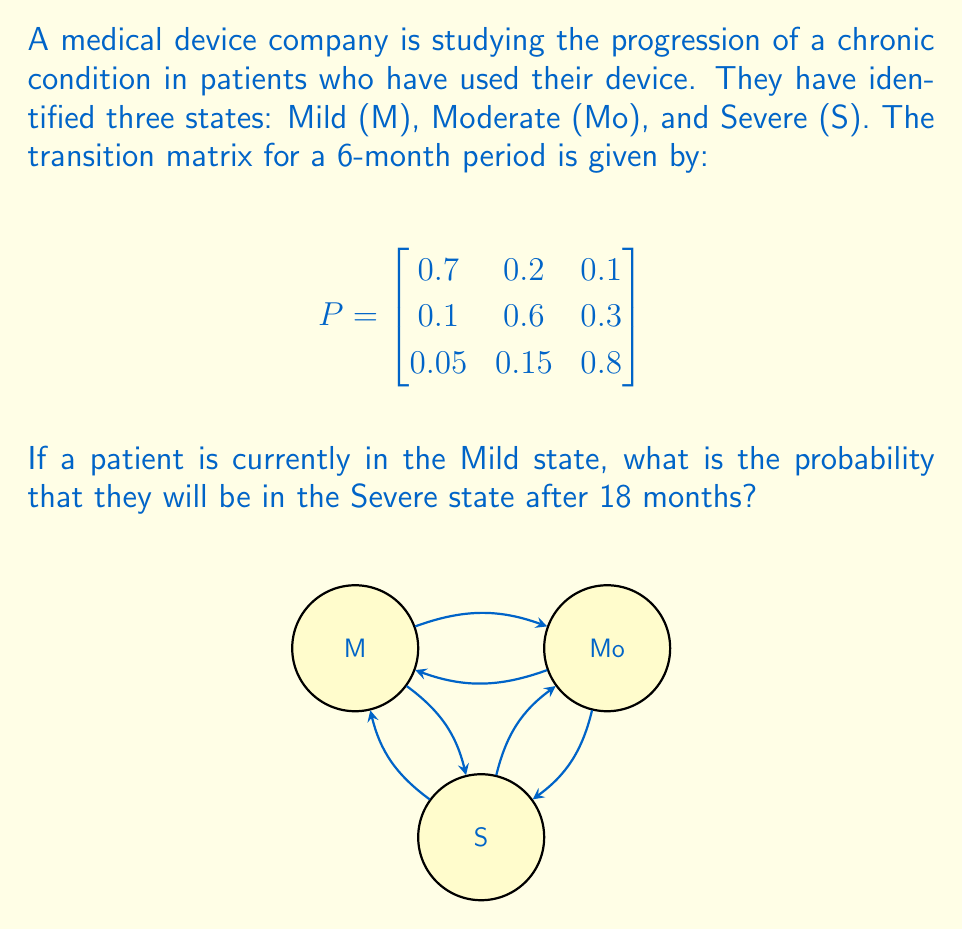Help me with this question. To solve this problem, we need to use the properties of Markov chains and transition matrices. Here's a step-by-step approach:

1) First, we need to calculate the transition matrix for 18 months. Since the given matrix is for a 6-month period, and 18 months is 3 times 6 months, we need to raise the matrix to the power of 3.

2) Let's call the 18-month transition matrix $P^3$. We can calculate this using matrix multiplication:

   $P^3 = P \times P \times P$

3) Using a calculator or computer algebra system, we get:

   $$
   P^3 = \begin{bmatrix}
   0.37 & 0.31 & 0.32 \\
   0.1825 & 0.3525 & 0.465 \\
   0.1075 & 0.2475 & 0.645
   \end{bmatrix}
   $$

4) Now, we need to look at the probability of transitioning from the Mild state (M) to the Severe state (S) after 18 months. This is given by the element in the first row, third column of $P^3$.

5) From the matrix $P^3$, we can see that this probability is 0.32 or 32%.

Therefore, the probability that a patient currently in the Mild state will be in the Severe state after 18 months is 0.32 or 32%.
Answer: 0.32 